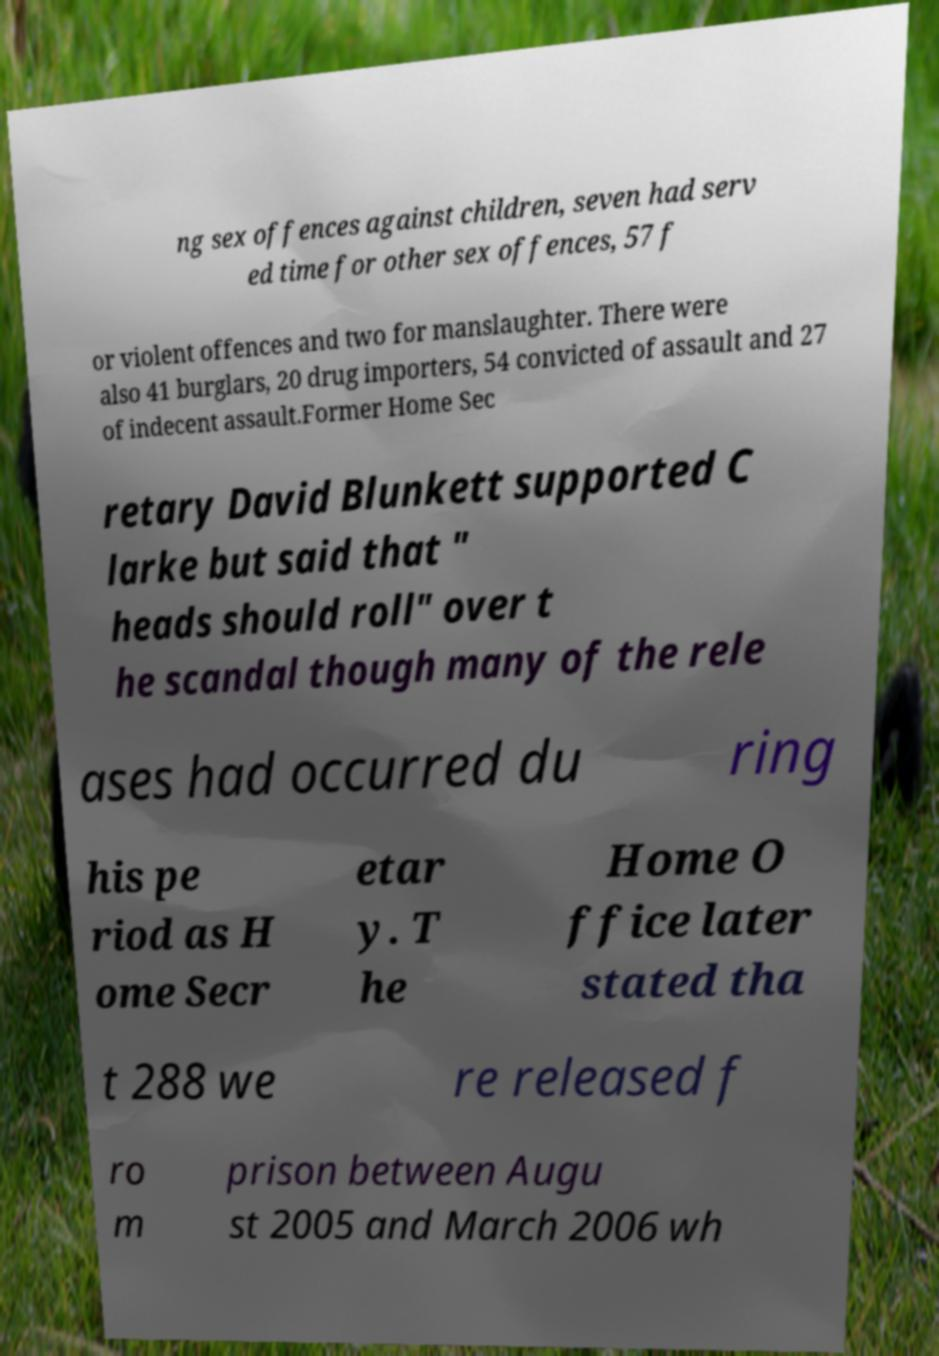Can you read and provide the text displayed in the image?This photo seems to have some interesting text. Can you extract and type it out for me? ng sex offences against children, seven had serv ed time for other sex offences, 57 f or violent offences and two for manslaughter. There were also 41 burglars, 20 drug importers, 54 convicted of assault and 27 of indecent assault.Former Home Sec retary David Blunkett supported C larke but said that " heads should roll" over t he scandal though many of the rele ases had occurred du ring his pe riod as H ome Secr etar y. T he Home O ffice later stated tha t 288 we re released f ro m prison between Augu st 2005 and March 2006 wh 